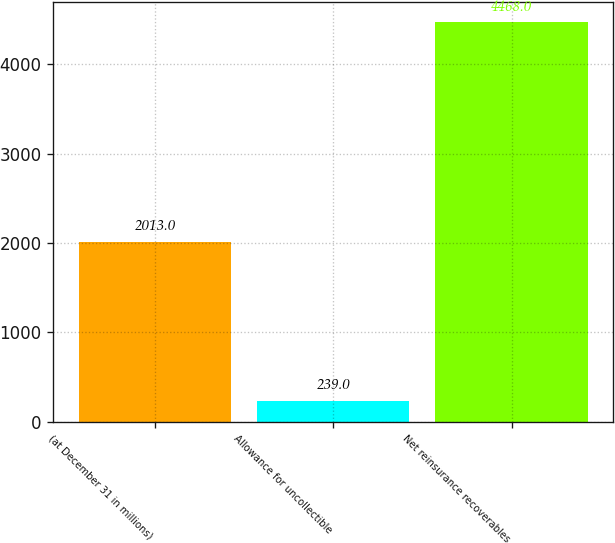Convert chart. <chart><loc_0><loc_0><loc_500><loc_500><bar_chart><fcel>(at December 31 in millions)<fcel>Allowance for uncollectible<fcel>Net reinsurance recoverables<nl><fcel>2013<fcel>239<fcel>4468<nl></chart> 